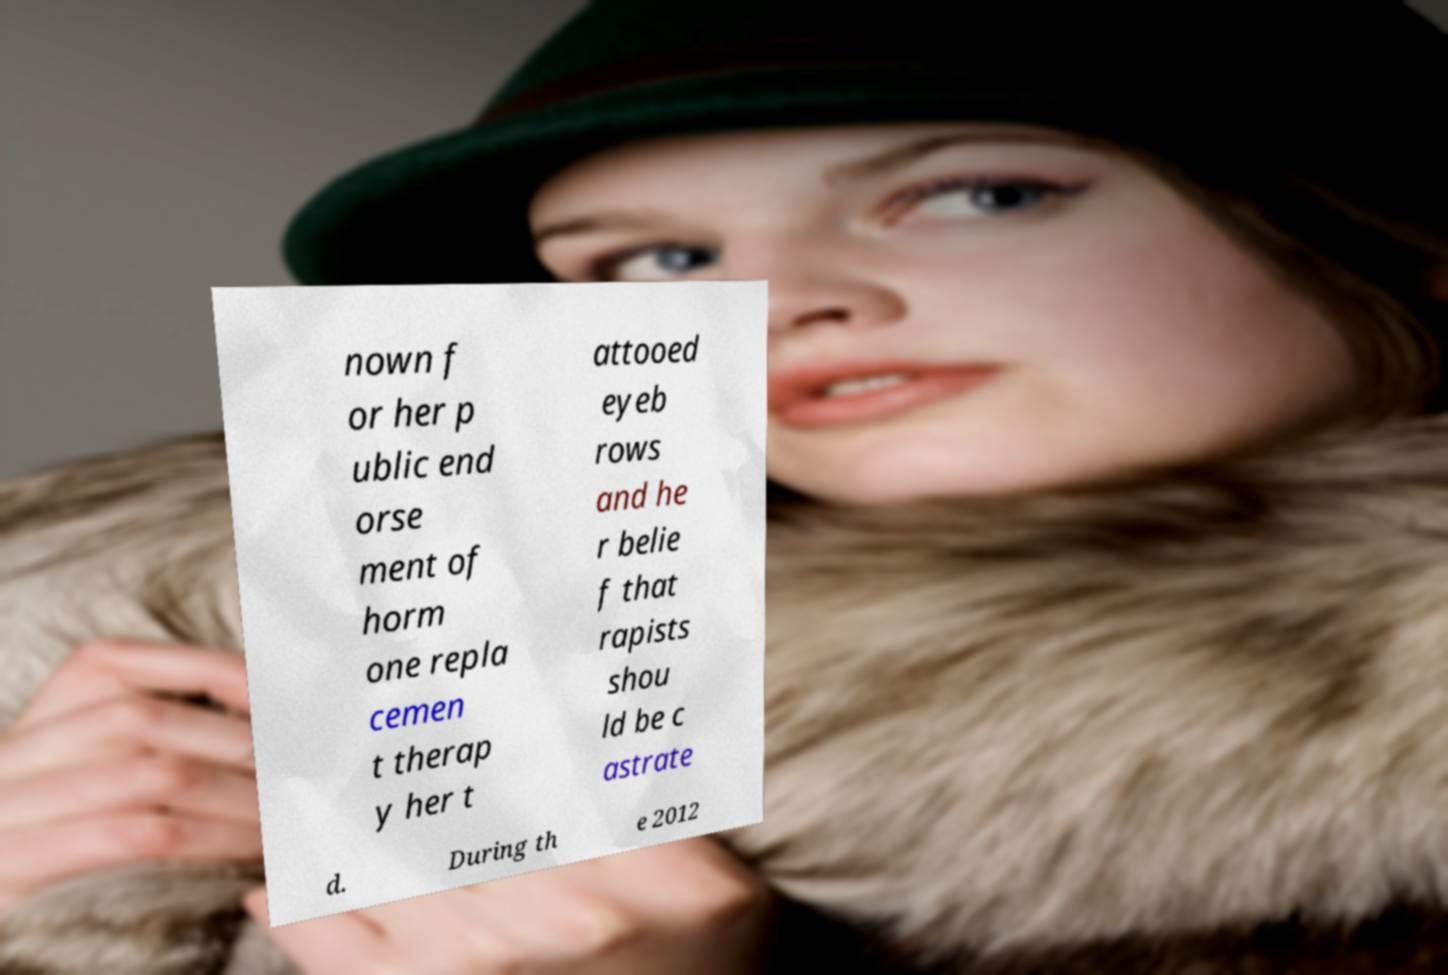Please read and relay the text visible in this image. What does it say? nown f or her p ublic end orse ment of horm one repla cemen t therap y her t attooed eyeb rows and he r belie f that rapists shou ld be c astrate d. During th e 2012 